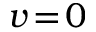<formula> <loc_0><loc_0><loc_500><loc_500>v \, = \, 0</formula> 